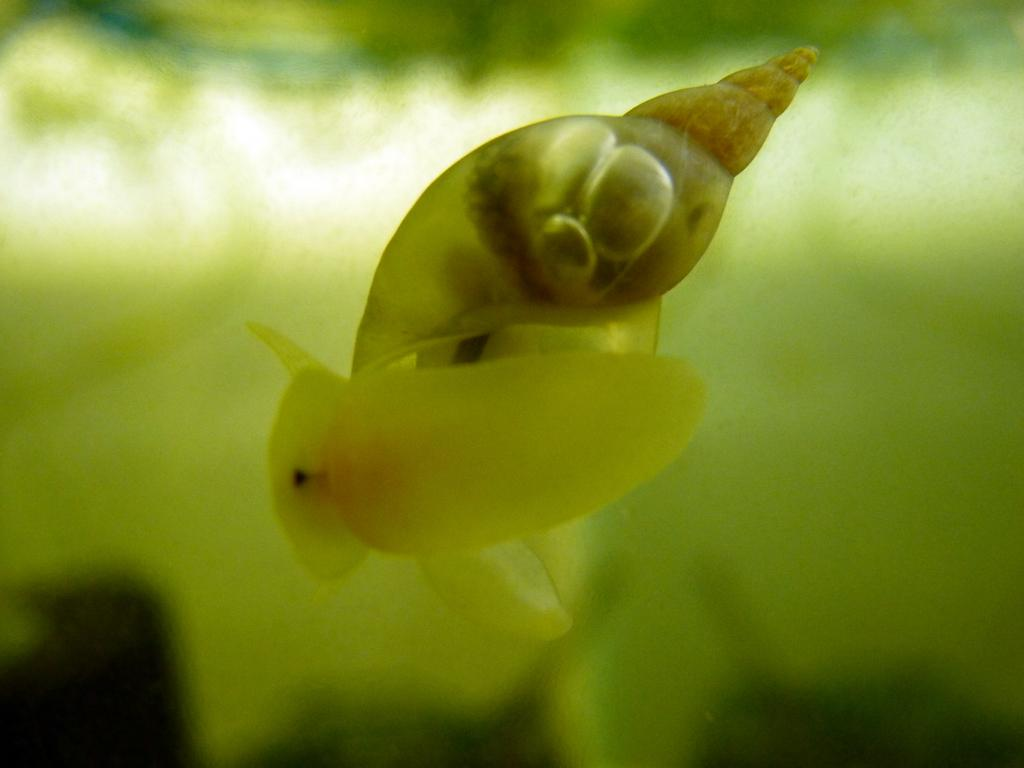What is the main subject of the image? There is a snail in the water in the image. Can you describe the background of the image? The background of the image is blurry. What type of credit card is visible in the image? There is no credit card present in the image; it features a snail in the water with a blurry background. What color is the pear in the image? There is no pear present in the image; it features a snail in the water with a blurry background. 